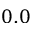Convert formula to latex. <formula><loc_0><loc_0><loc_500><loc_500>0 . 0</formula> 